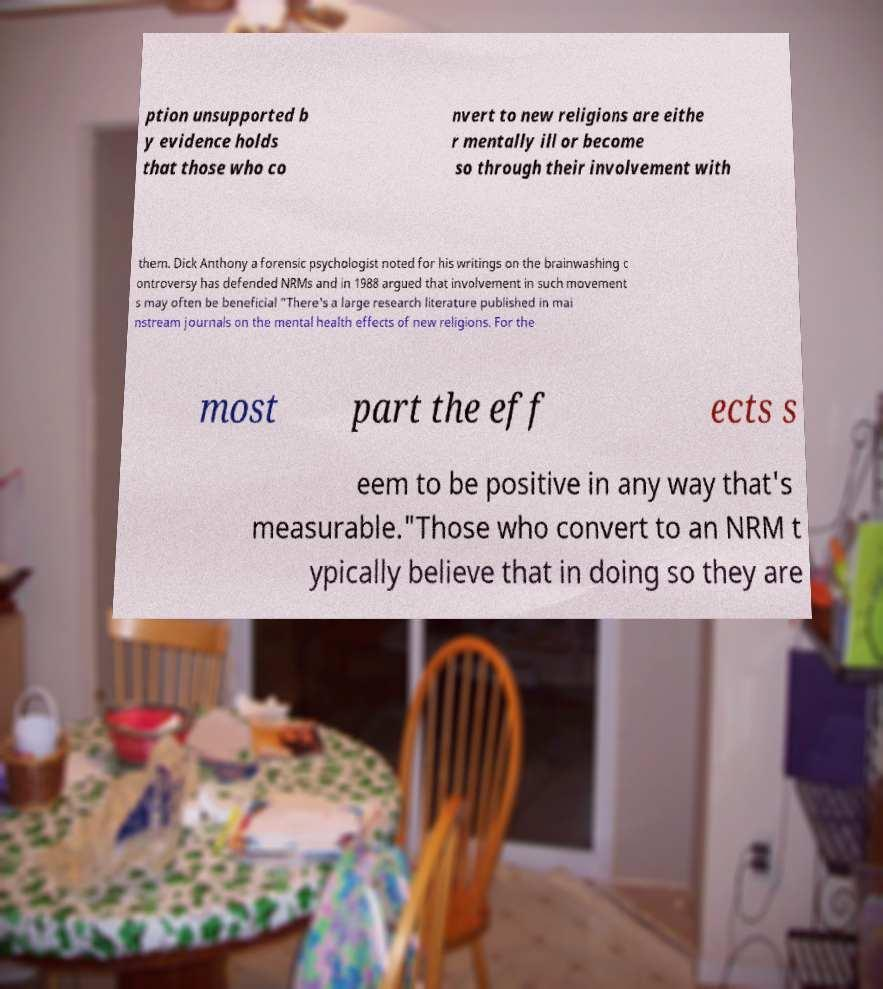Please identify and transcribe the text found in this image. ption unsupported b y evidence holds that those who co nvert to new religions are eithe r mentally ill or become so through their involvement with them. Dick Anthony a forensic psychologist noted for his writings on the brainwashing c ontroversy has defended NRMs and in 1988 argued that involvement in such movement s may often be beneficial "There's a large research literature published in mai nstream journals on the mental health effects of new religions. For the most part the eff ects s eem to be positive in any way that's measurable."Those who convert to an NRM t ypically believe that in doing so they are 